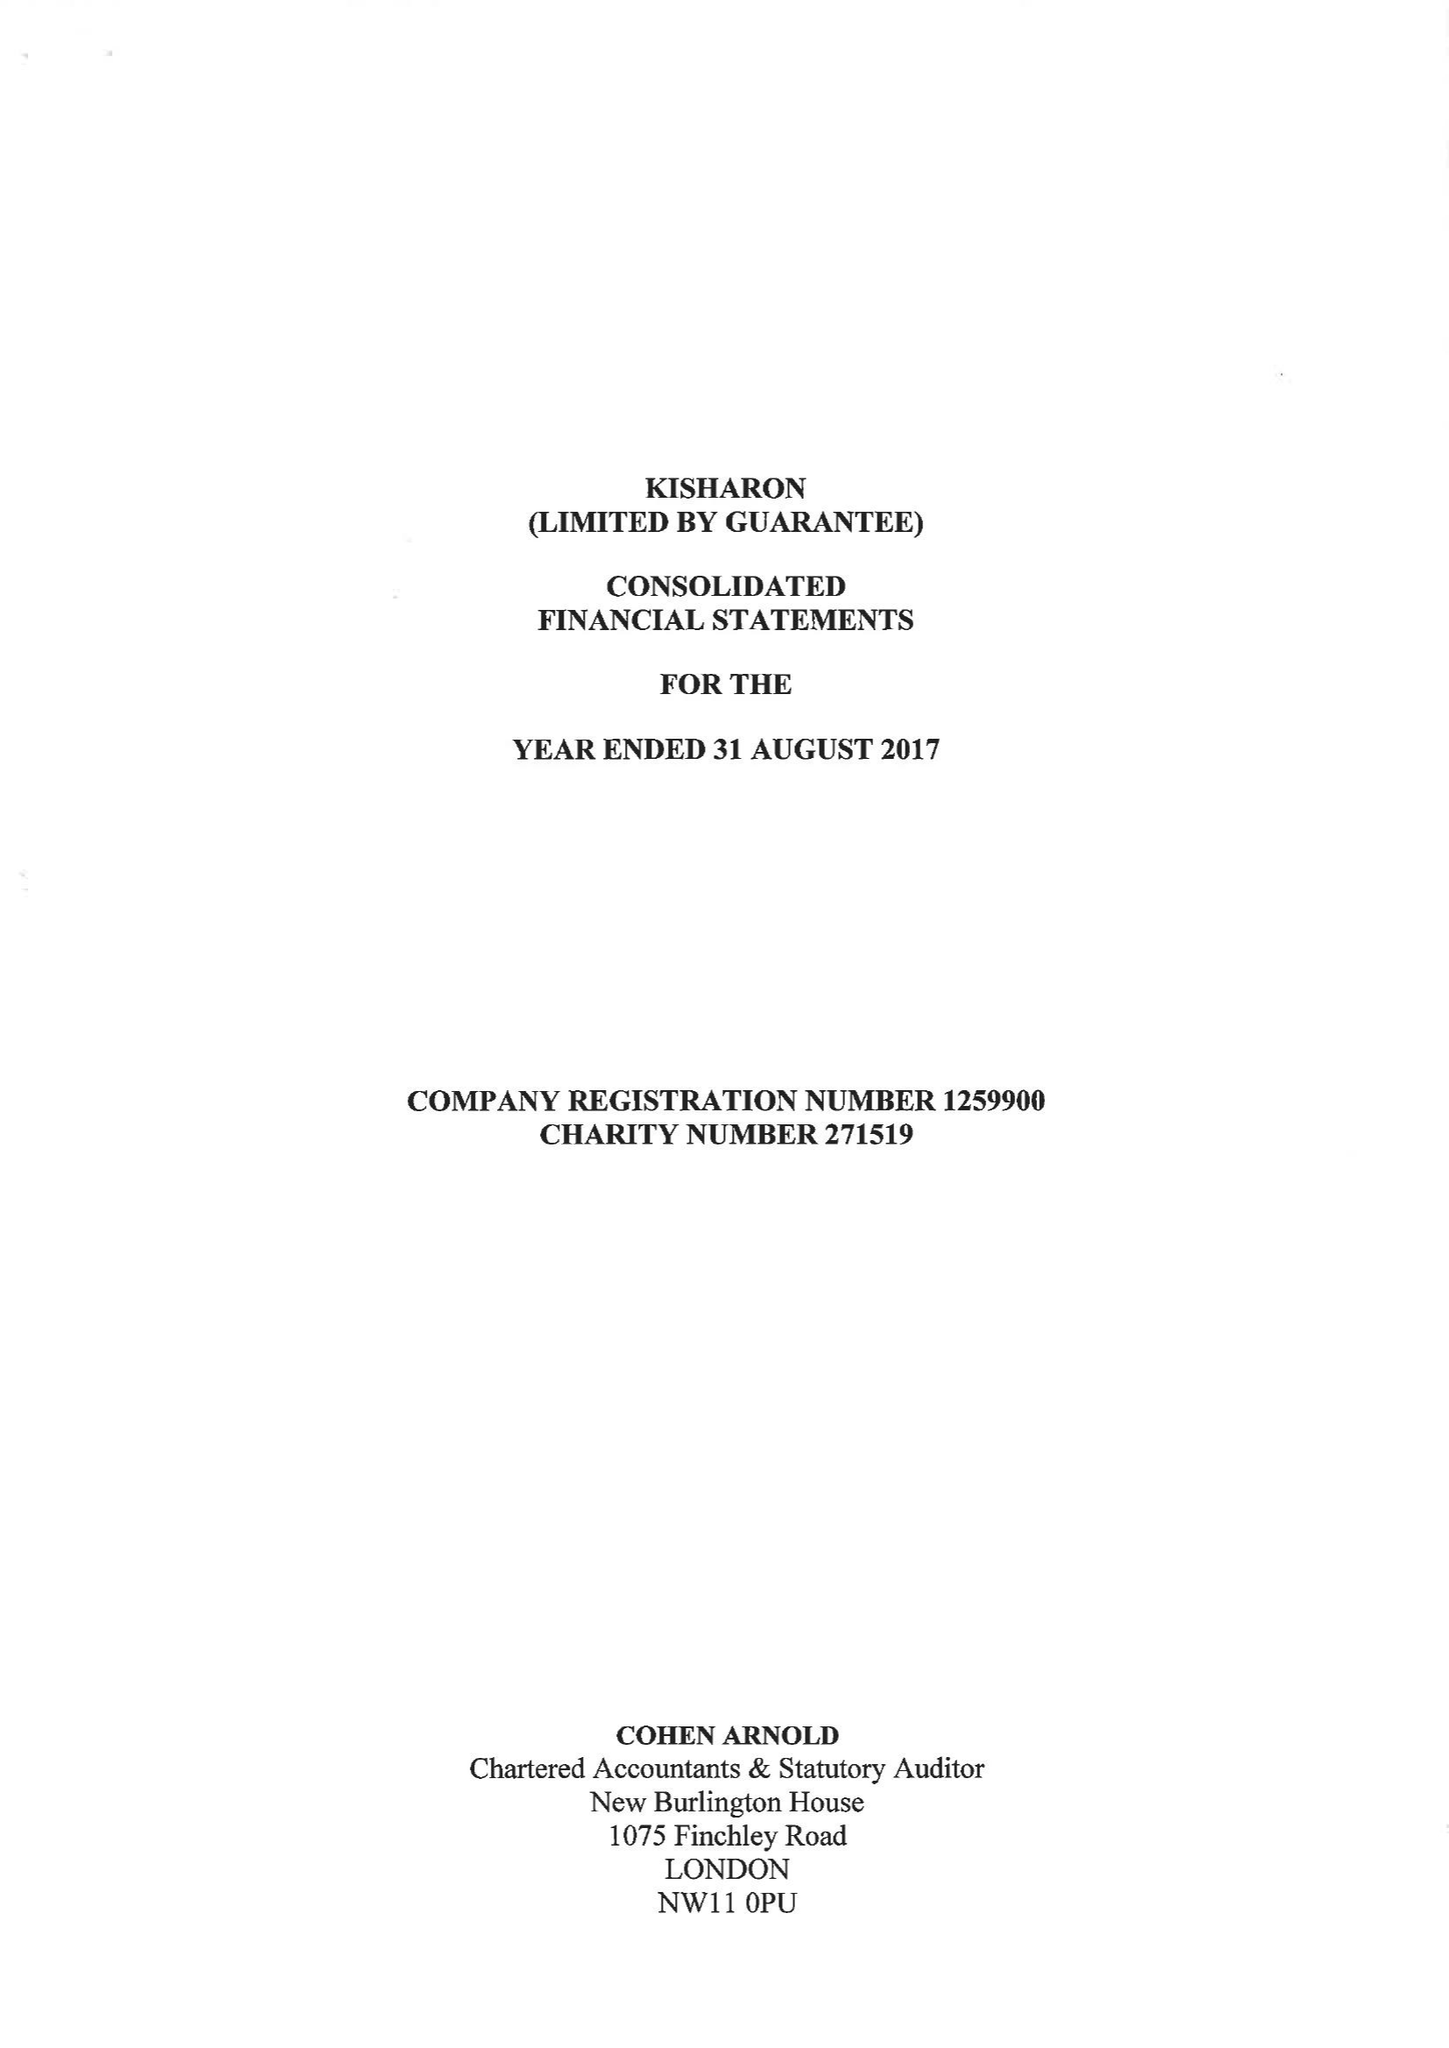What is the value for the charity_name?
Answer the question using a single word or phrase. Kisharon 